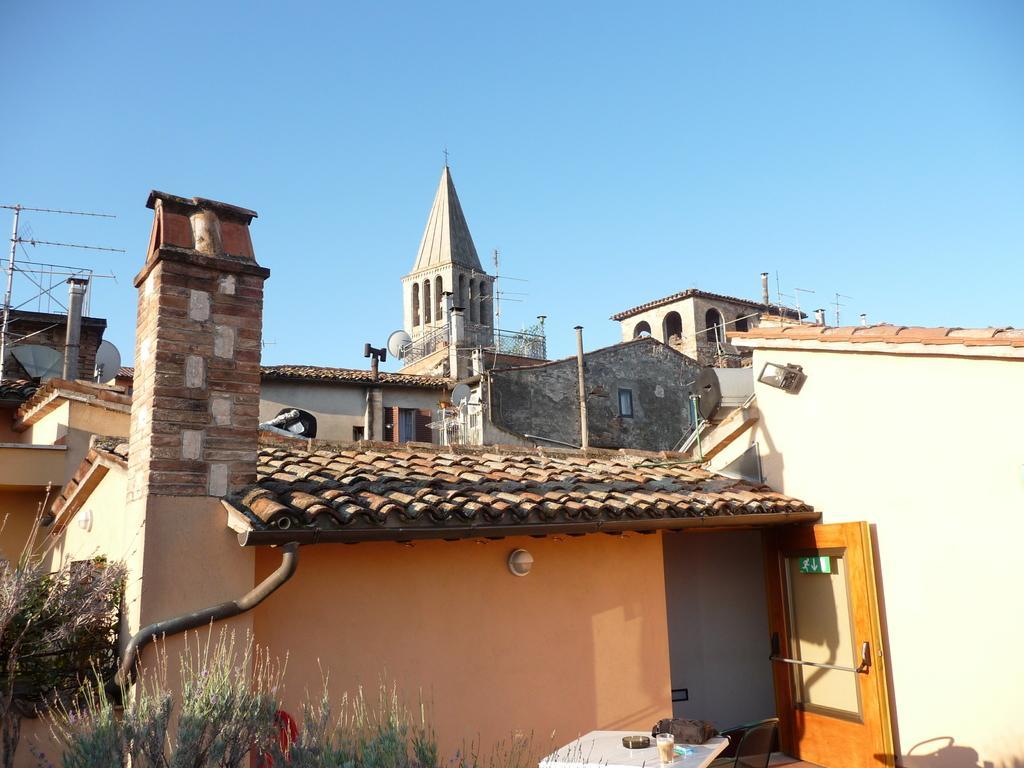Could you give a brief overview of what you see in this image? In this picture there are few buildings and the sky is in blue color. 